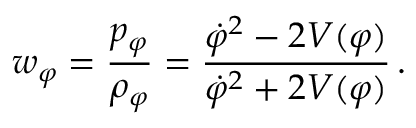Convert formula to latex. <formula><loc_0><loc_0><loc_500><loc_500>w _ { \varphi } = \frac { p _ { \varphi } } { { \rho } _ { \varphi } } = \frac { { \dot { \varphi } } ^ { 2 } - 2 V ( \varphi ) } { { \dot { \varphi } } ^ { 2 } + 2 V ( \varphi ) } \, .</formula> 